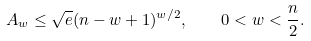<formula> <loc_0><loc_0><loc_500><loc_500>A _ { w } \leq \sqrt { e } ( n - w + 1 ) ^ { w / 2 } , \quad 0 < w < \frac { n } { 2 } .</formula> 